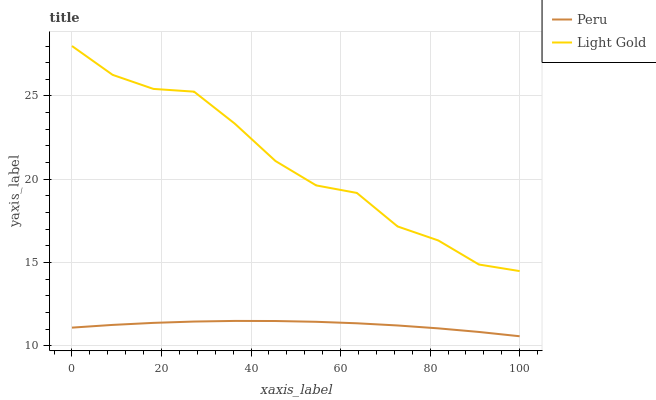Does Peru have the minimum area under the curve?
Answer yes or no. Yes. Does Light Gold have the maximum area under the curve?
Answer yes or no. Yes. Does Peru have the maximum area under the curve?
Answer yes or no. No. Is Peru the smoothest?
Answer yes or no. Yes. Is Light Gold the roughest?
Answer yes or no. Yes. Is Peru the roughest?
Answer yes or no. No. Does Peru have the lowest value?
Answer yes or no. Yes. Does Light Gold have the highest value?
Answer yes or no. Yes. Does Peru have the highest value?
Answer yes or no. No. Is Peru less than Light Gold?
Answer yes or no. Yes. Is Light Gold greater than Peru?
Answer yes or no. Yes. Does Peru intersect Light Gold?
Answer yes or no. No. 